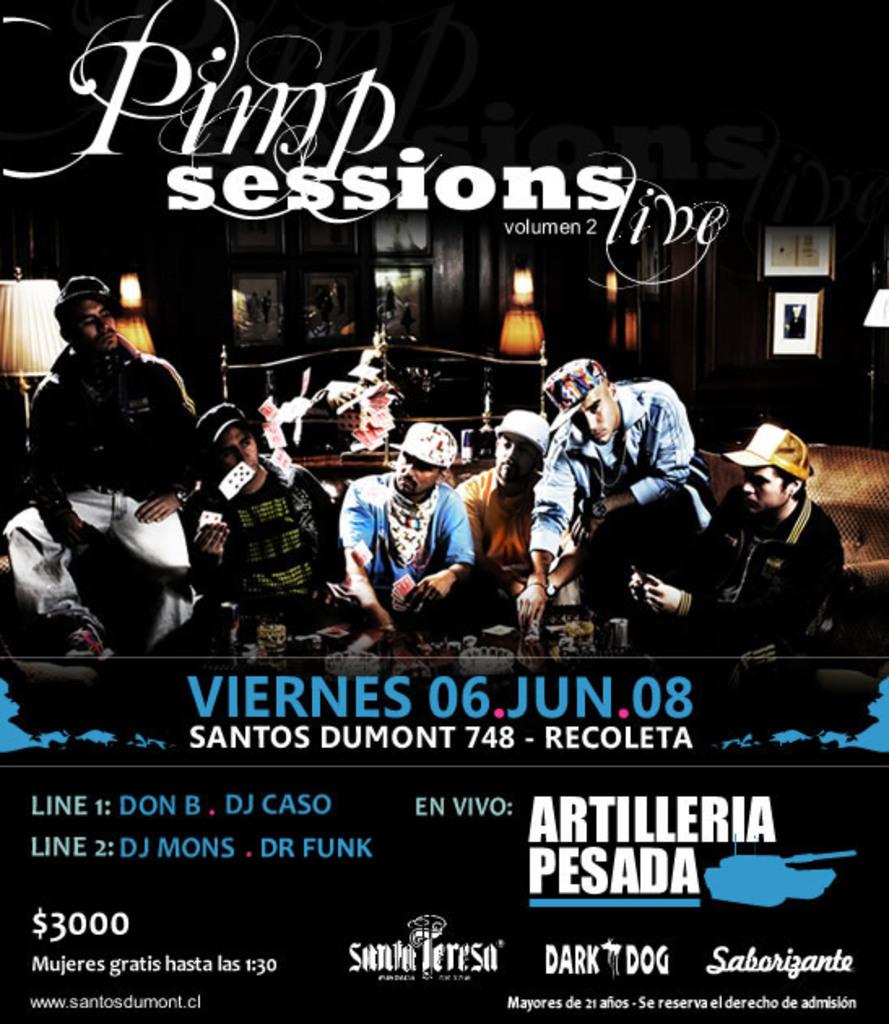What date was this event on?
Give a very brief answer. 06 jun 08. What sessions were these?
Ensure brevity in your answer.  Pimp. 